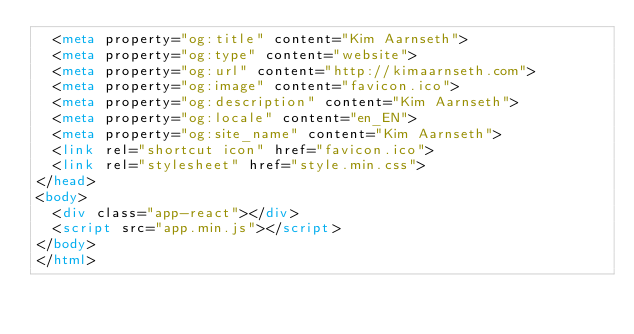<code> <loc_0><loc_0><loc_500><loc_500><_HTML_>	<meta property="og:title" content="Kim Aarnseth">
	<meta property="og:type" content="website">
	<meta property="og:url" content="http://kimaarnseth.com">
	<meta property="og:image" content="favicon.ico">
	<meta property="og:description" content="Kim Aarnseth">
	<meta property="og:locale" content="en_EN">
	<meta property="og:site_name" content="Kim Aarnseth">
	<link rel="shortcut icon" href="favicon.ico">
	<link rel="stylesheet" href="style.min.css">
</head>
<body>
	<div class="app-react"></div>
	<script src="app.min.js"></script>
</body>
</html>
</code> 